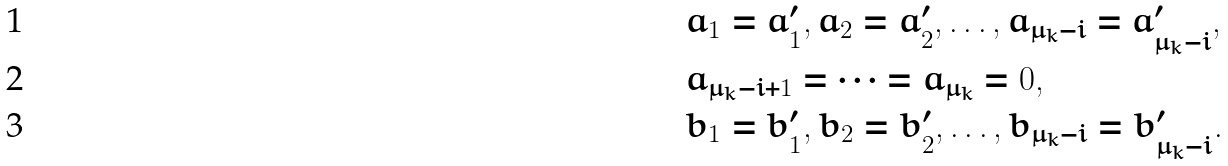Convert formula to latex. <formula><loc_0><loc_0><loc_500><loc_500>& a _ { 1 } = a ^ { \prime } _ { 1 } , a _ { 2 } = a ^ { \prime } _ { 2 } , \dots , a _ { \mu _ { k } - i } = a ^ { \prime } _ { \mu _ { k } - i } , \\ & a _ { \mu _ { k } - i + 1 } = \cdots = a _ { \mu _ { k } } = 0 , \\ & b _ { 1 } = b ^ { \prime } _ { 1 } , b _ { 2 } = b ^ { \prime } _ { 2 } , \dots , b _ { \mu _ { k } - i } = b ^ { \prime } _ { \mu _ { k } - i } .</formula> 